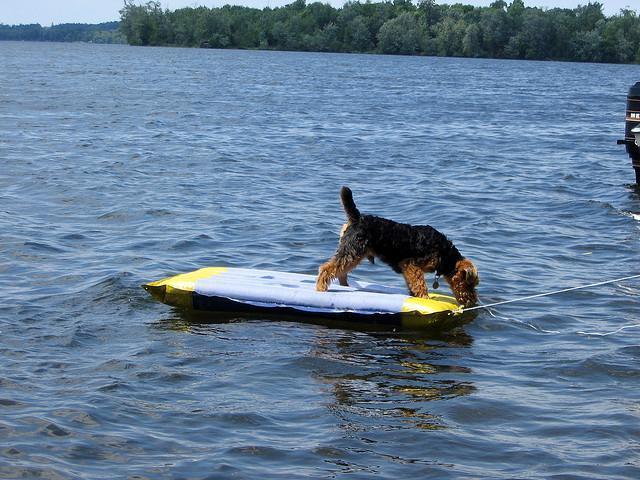How many dogs are there?
Give a very brief answer. 1. 